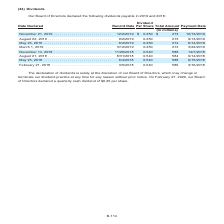According to Centurylink's financial document, What can the Board of Directors do regarding the declaration of dividends? may change or terminate our dividend practice at any time for any reason without prior notice. The document states: "t the discretion of our Board of Directors, which may change or terminate our dividend practice at any time for any reason without prior notice. On Fe..." Also, What was the per share value of dividends declared on February 27, 2020? quarterly cash dividend of $0.25 per share. The document states: "ruary 27, 2020, our Board of Directors declared a quarterly cash dividend of $0.25 per share...." Also, What were the dates where the Board of Directors declared the dividends payable in the table? The document contains multiple relevant values: November 21, 2019, August 22, 2019, May 23, 2019, March 1, 2019, November 14, 2018, August 21, 2018, May 23, 2018, February 21, 2018. From the document: "ovember 14, 2018 . 11/26/2018 0.540 586 12/7/2018 August 21, 2018 . 8/31/2018 0.540 584 9/14/2018 May 23, 2018 . 6/4/2018 0.540 588 6/15/2018 February..." Also, How many different dates did the Board of Directors declare the dividends payable in 2018 and 2019? Counting the relevant items in the document: November 21, 2019, August 22, 2019, May 23, 2019, March 1, 2019, November 14, 2018, August 21, 2018, May 23, 2018, February 21, 2018, I find 8 instances. The key data points involved are: August 21, 2018, August 22, 2019, February 21, 2018. Also, How many different dates declared had a dividend per share of $0.250 in 2018 and 2019? Counting the relevant items in the document: November 21, 2019, August 22, 2019, May 23, 2019, March 1, 2019, I find 4 instances. The key data points involved are: August 22, 2019, March 1, 2019, May 23, 2019. Also, can you calculate: What is the average total amount of dividend value for 2018 and 2019? To answer this question, I need to perform calculations using the financial data. The calculation is: (273+273+274+273+586+584+588+586)/8, which equals 429.62 (in millions). This is based on the information: "0 586 12/7/2018 August 21, 2018 . 8/31/2018 0.540 584 9/14/2018 May 23, 2018 . 6/4/2018 0.540 588 6/15/2018 February 21, 2018 . 3/5/2018 0.540 586 3/16/2 73 3/22/2019 November 14, 2018 . 11/26/2018 0...." The key data points involved are: 273, 274, 584. 